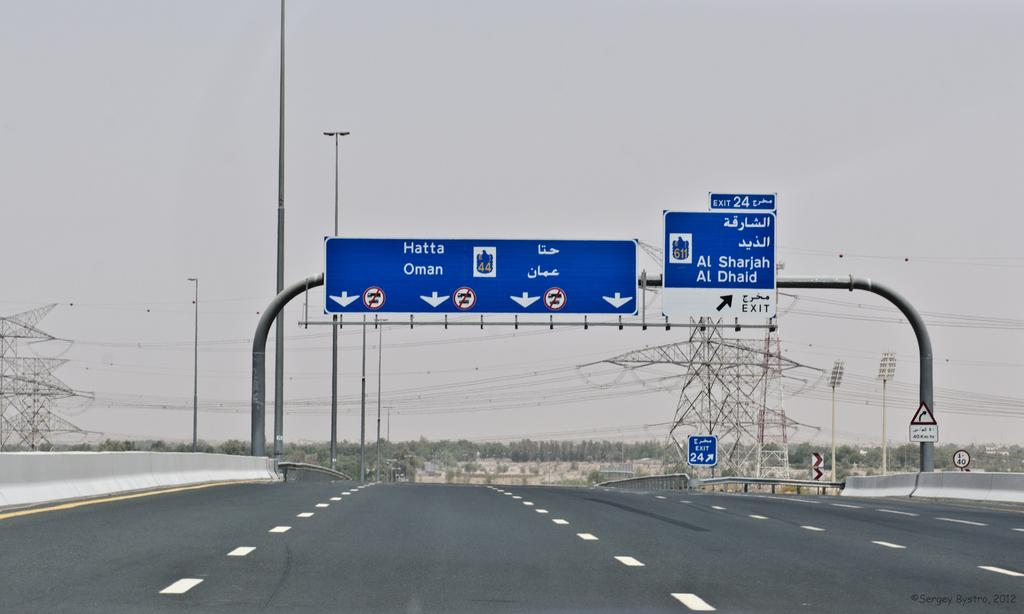<image>
Create a compact narrative representing the image presented. An empty road and directional road signs displaying the destinations for exit 24. 